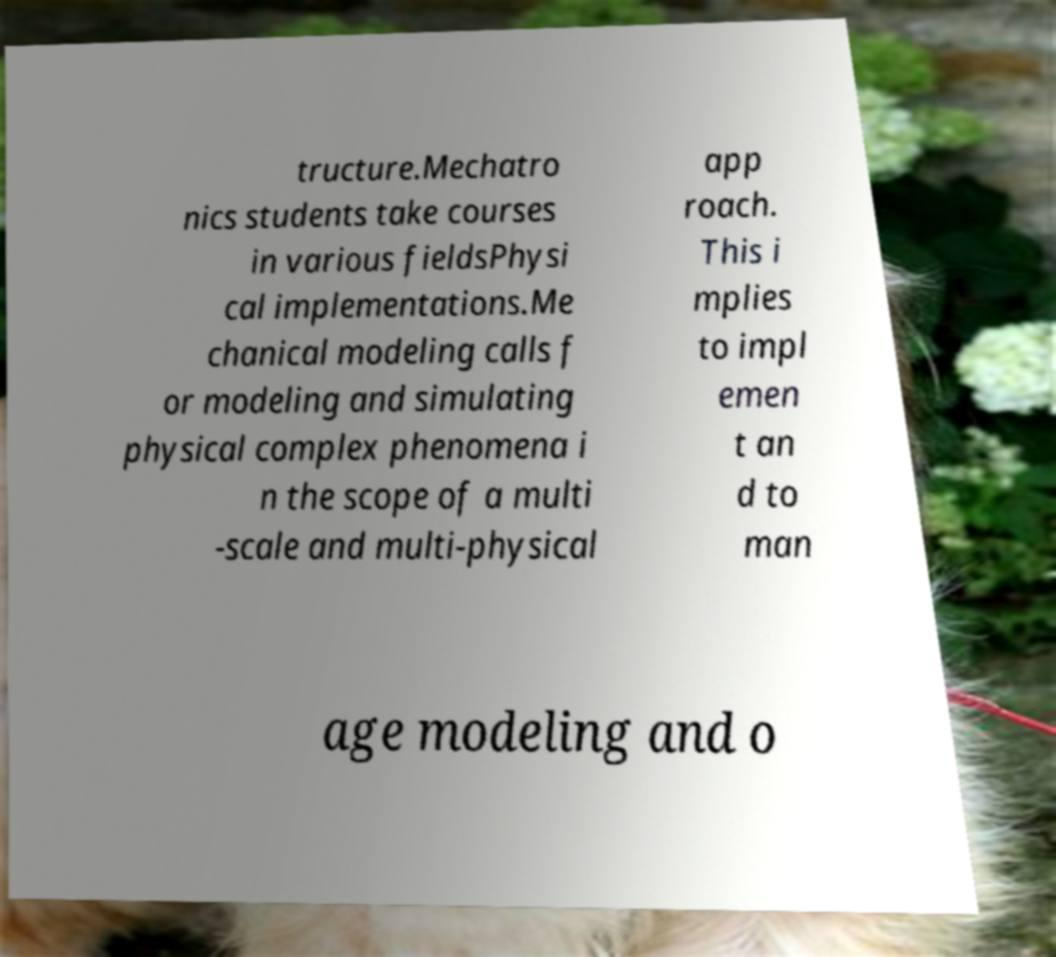Could you assist in decoding the text presented in this image and type it out clearly? tructure.Mechatro nics students take courses in various fieldsPhysi cal implementations.Me chanical modeling calls f or modeling and simulating physical complex phenomena i n the scope of a multi -scale and multi-physical app roach. This i mplies to impl emen t an d to man age modeling and o 